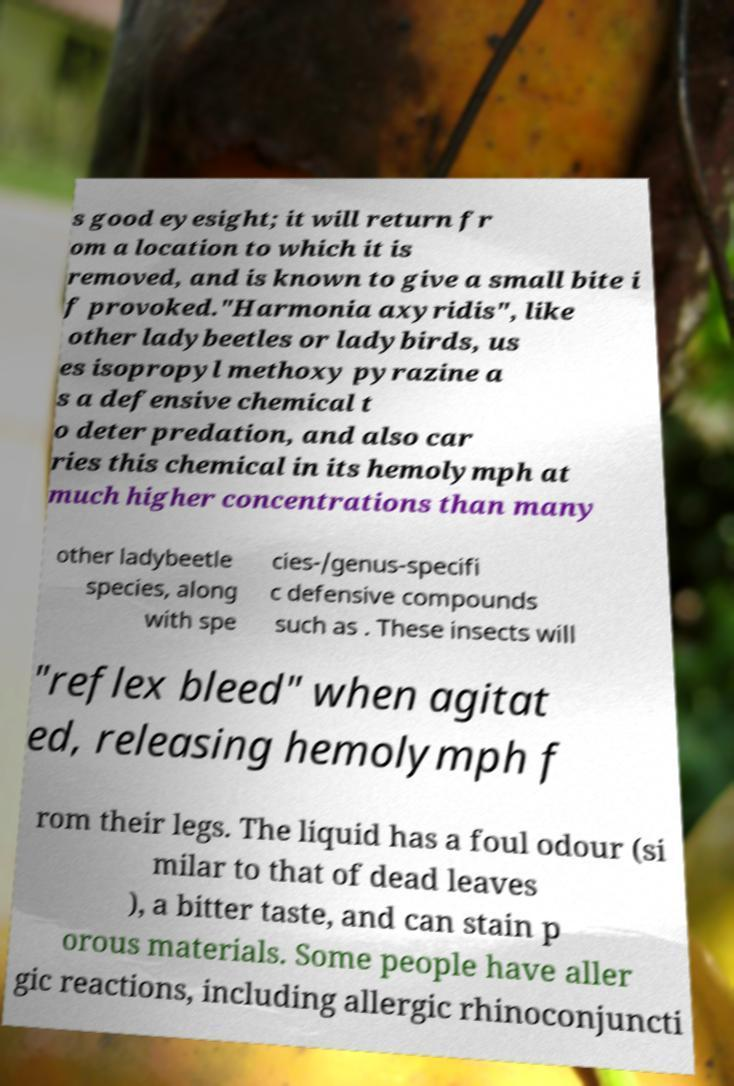Can you read and provide the text displayed in the image?This photo seems to have some interesting text. Can you extract and type it out for me? s good eyesight; it will return fr om a location to which it is removed, and is known to give a small bite i f provoked."Harmonia axyridis", like other ladybeetles or ladybirds, us es isopropyl methoxy pyrazine a s a defensive chemical t o deter predation, and also car ries this chemical in its hemolymph at much higher concentrations than many other ladybeetle species, along with spe cies-/genus-specifi c defensive compounds such as . These insects will "reflex bleed" when agitat ed, releasing hemolymph f rom their legs. The liquid has a foul odour (si milar to that of dead leaves ), a bitter taste, and can stain p orous materials. Some people have aller gic reactions, including allergic rhinoconjuncti 